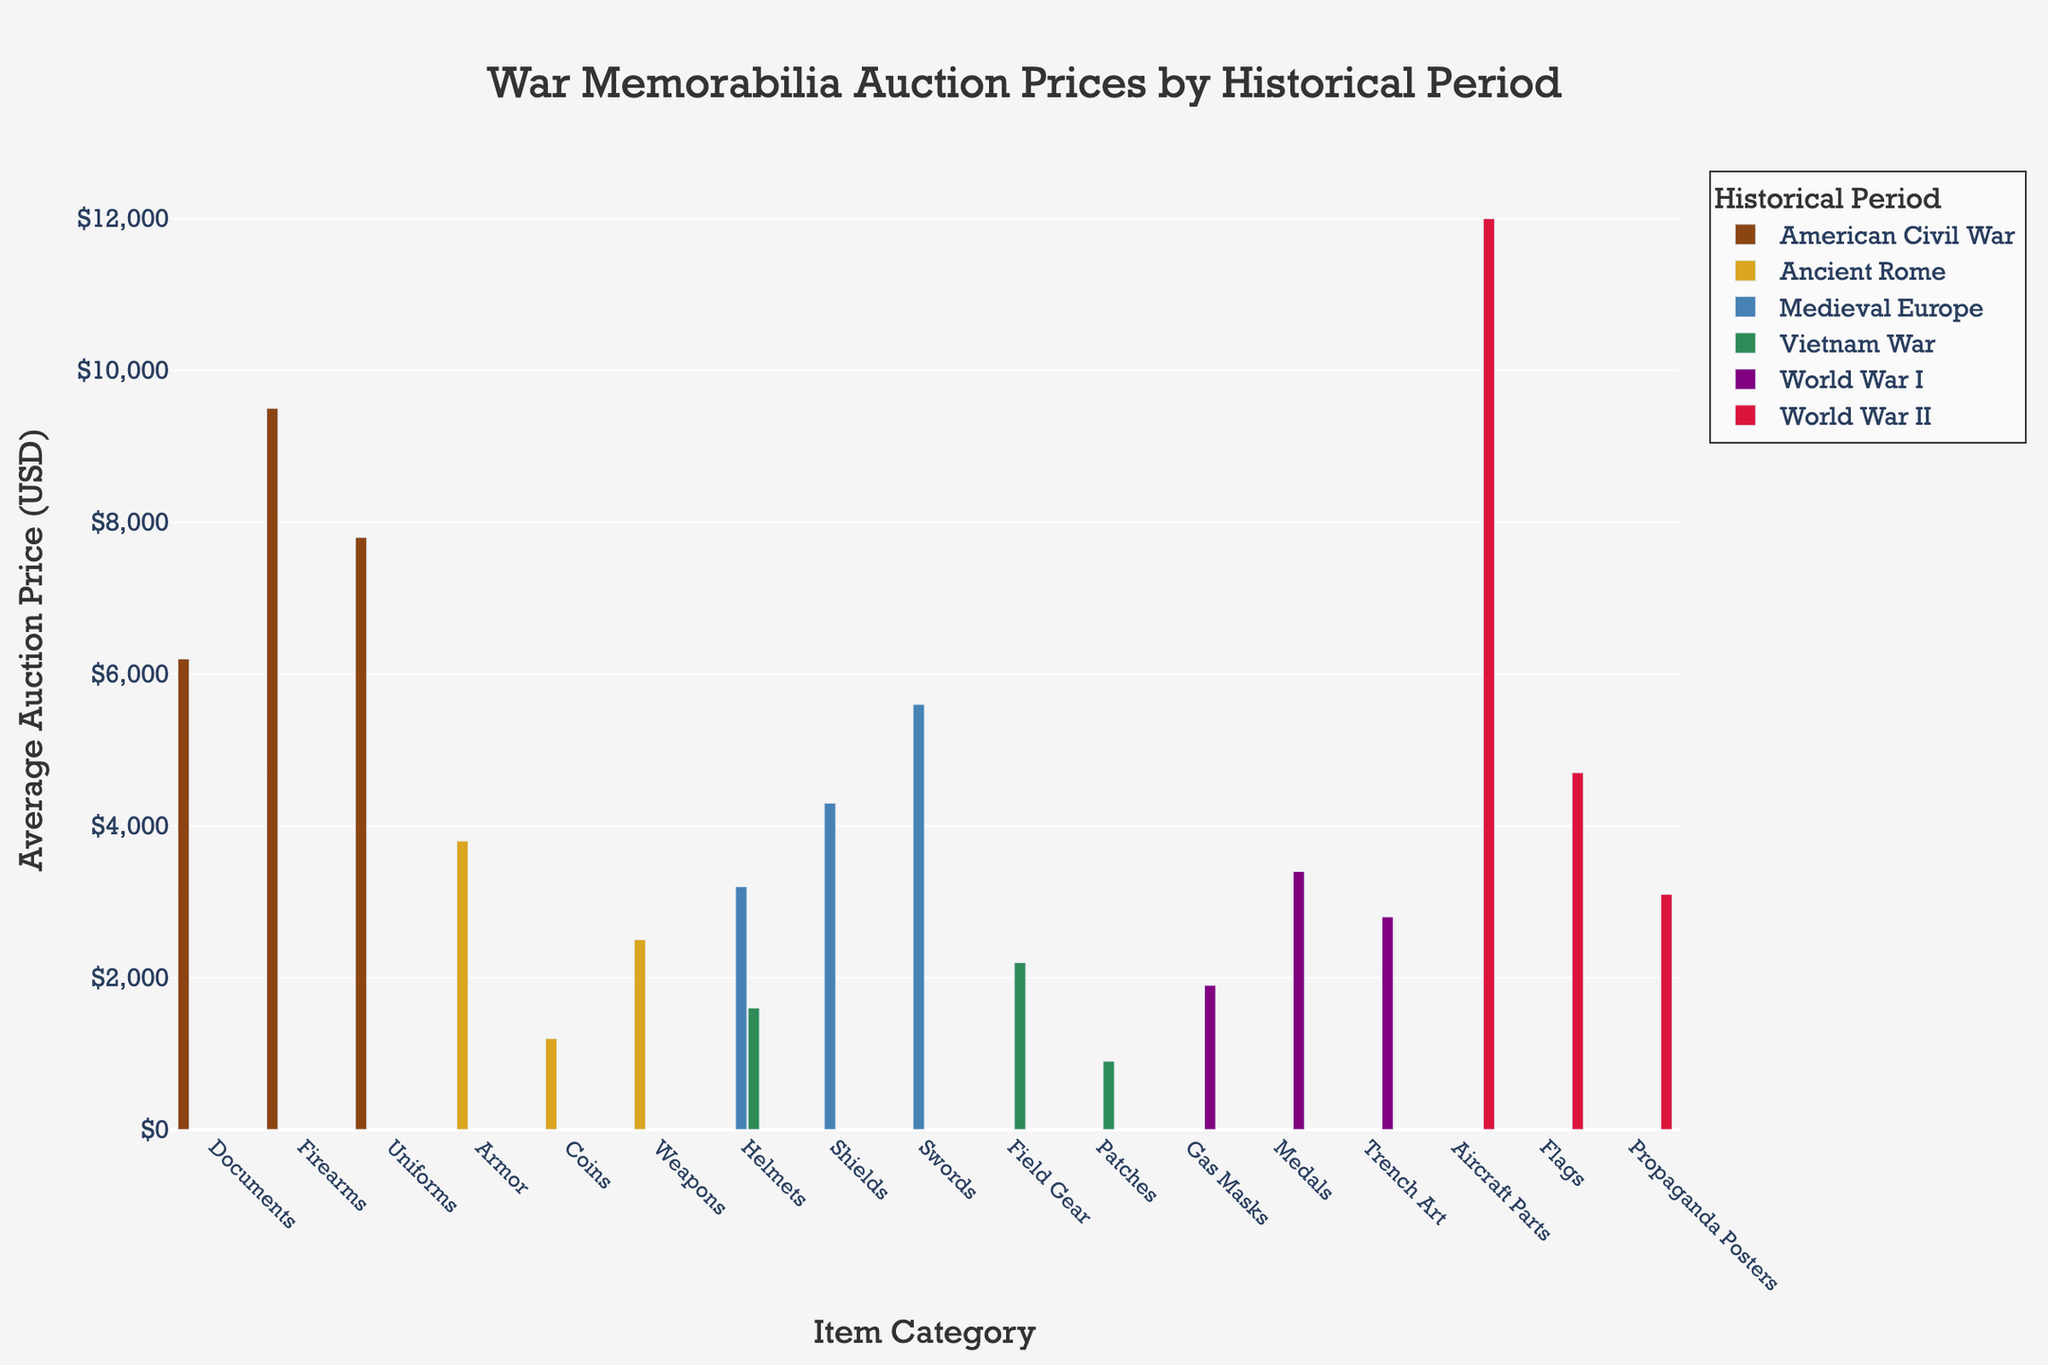what is the title of the plot? The title of the plot is located at the top center of the figure and is displayed prominently. It summarizes the content of the plot.
Answer: War Memorabilia Auction Prices by Historical Period What is the average auction price for items from World War II? Identify the bar heights for each item category in World War II and average these values: Aircraft Parts ($12,000), Flags ($4,700), and Propaganda Posters ($3,100). Sum these values and divide by the number of categories: (12000 + 4700 + 3100) / 3.
Answer: $6,600 Which historical period has the highest average auction price for any single item category? Compare the maximum bar height in each historical period. The highest bar overall corresponds to the Auction Price USD for Aircraft Parts from World War II, which is $12,000.
Answer: World War II Which historical period has the lowest average auction price for any single item category, and what is that item? Locate the shortest bar in the figure and its corresponding historical period and item category. The shortest bar is for the Vietnam War with Patches having an auction price of $900.
Answer: Vietnam War, Patches How many item categories are represented for the American Civil War? Count the number of bars corresponding to the American Civil War. Each bar represents a different item category.
Answer: 3 What is the auction price difference between the highest and lowest-priced items from the Medieval Europe period? Identify the highest and lowest bar heights for the Medieval Europe period. The highest is Swords ($5,600), and the lowest is Helmets ($3,200). Subtract the lowest from the highest: 5600 - 3200.
Answer: $2,400 What is the combined auction price for all items listed under the Vietnam War period? Sum the bar heights for the Vietnam War period: Helmets ($1,600), Patches ($900), and Field Gear ($2,200). Add these values together: 1600 + 900 + 2200.
Answer: $4,700 Which item category from Ancient Rome has the highest auction price? Observe the bars for Ancient Rome, the highest bar corresponds to Armor with an auction price of $3,800.
Answer: Armor Are there any historical periods where all item categories have auction prices above $3,000? Check each period to see if all item categories have bars above the $3,000 mark. Ancient Rome and Vietnam War both have items below $3,000. Medieval Europe, American Civil War, World War I, and World War II all have all items above $3,000 except for World War I with Gas Masks at $1,900.
Answer: No 